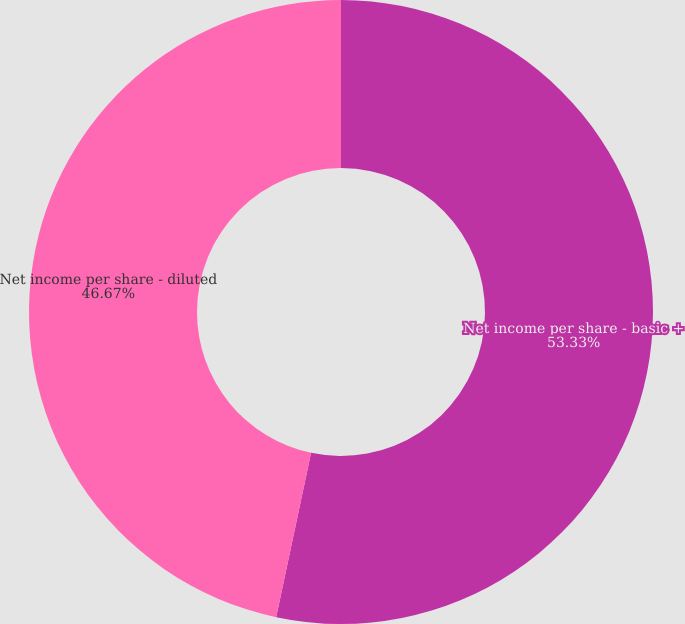Convert chart. <chart><loc_0><loc_0><loc_500><loc_500><pie_chart><fcel>Net income per share - basic +<fcel>Net income per share - diluted<nl><fcel>53.33%<fcel>46.67%<nl></chart> 